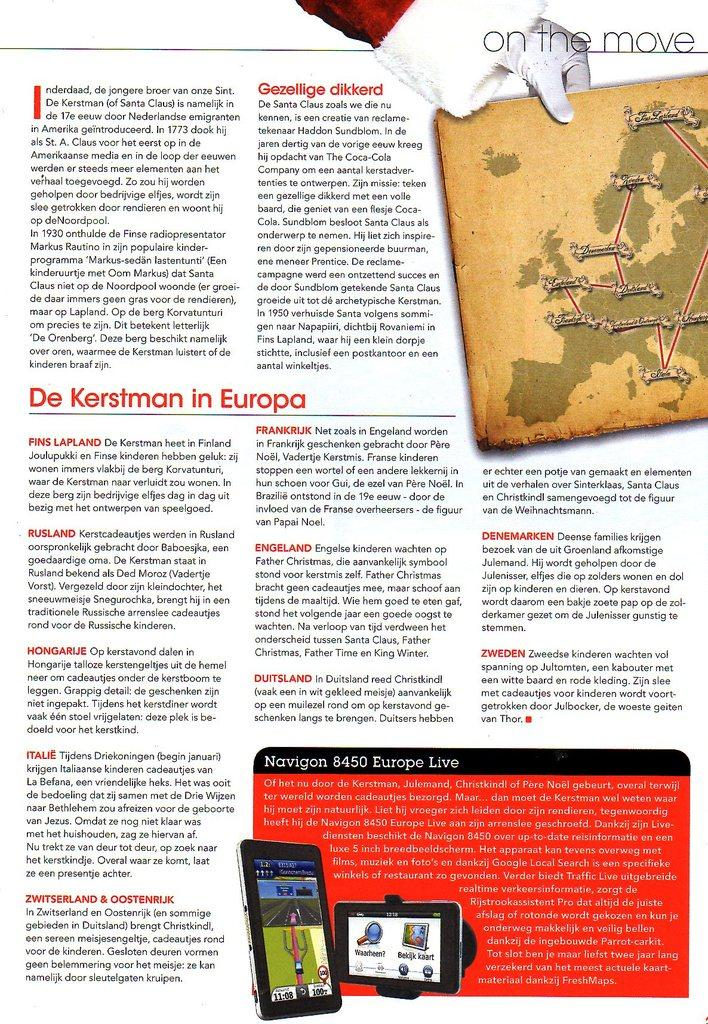Provide a one-sentence caption for the provided image. A page from a magazine, the title of the page is "On the move.". 